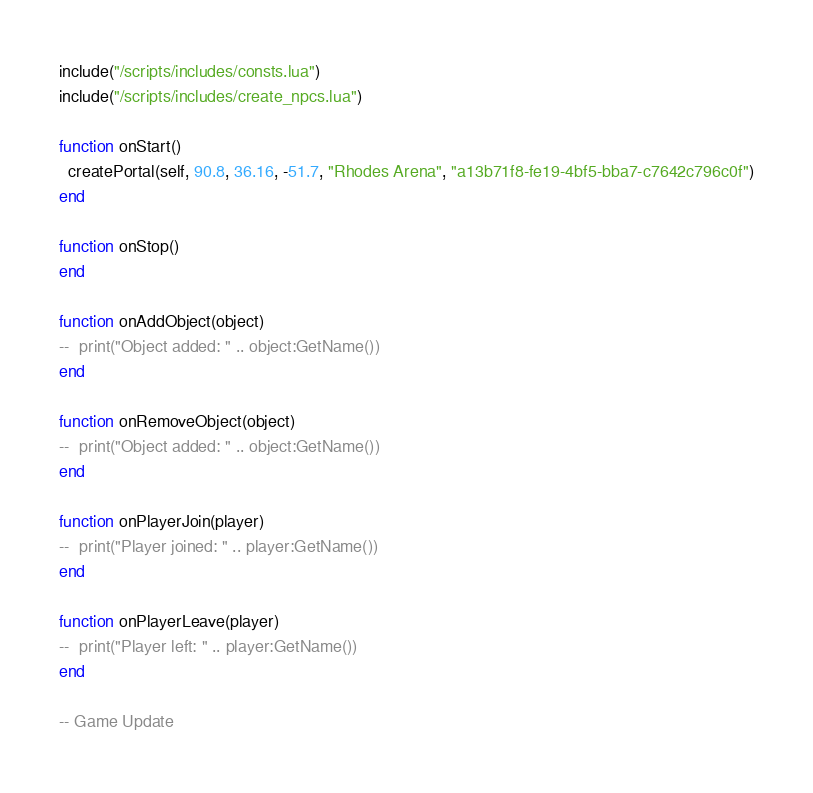<code> <loc_0><loc_0><loc_500><loc_500><_Lua_>include("/scripts/includes/consts.lua")
include("/scripts/includes/create_npcs.lua")

function onStart()
  createPortal(self, 90.8, 36.16, -51.7, "Rhodes Arena", "a13b71f8-fe19-4bf5-bba7-c7642c796c0f")
end

function onStop()
end

function onAddObject(object)
--  print("Object added: " .. object:GetName())
end

function onRemoveObject(object)
--  print("Object added: " .. object:GetName())
end

function onPlayerJoin(player)
--  print("Player joined: " .. player:GetName())
end

function onPlayerLeave(player)
--  print("Player left: " .. player:GetName())
end

-- Game Update</code> 